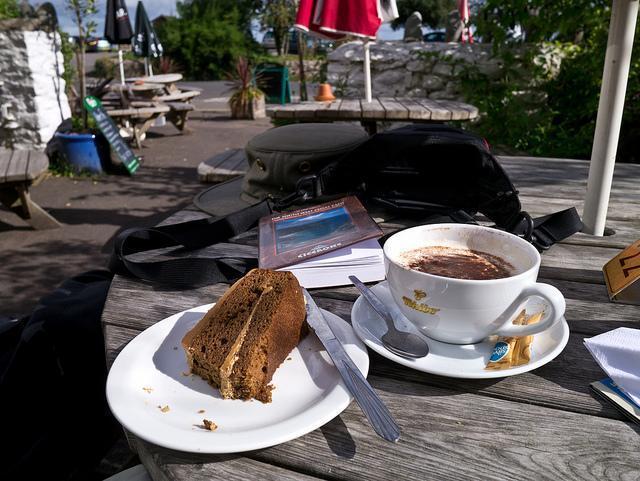How many umbrellas are there?
Give a very brief answer. 1. How many dining tables are in the picture?
Give a very brief answer. 2. How many potted plants can be seen?
Give a very brief answer. 1. 